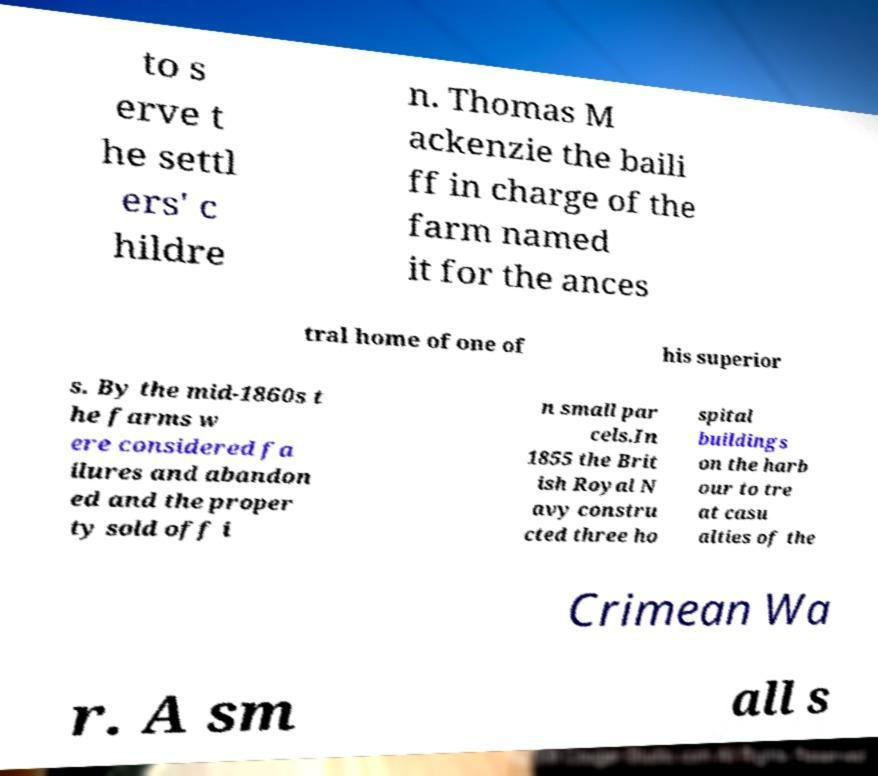For documentation purposes, I need the text within this image transcribed. Could you provide that? to s erve t he settl ers' c hildre n. Thomas M ackenzie the baili ff in charge of the farm named it for the ances tral home of one of his superior s. By the mid-1860s t he farms w ere considered fa ilures and abandon ed and the proper ty sold off i n small par cels.In 1855 the Brit ish Royal N avy constru cted three ho spital buildings on the harb our to tre at casu alties of the Crimean Wa r. A sm all s 